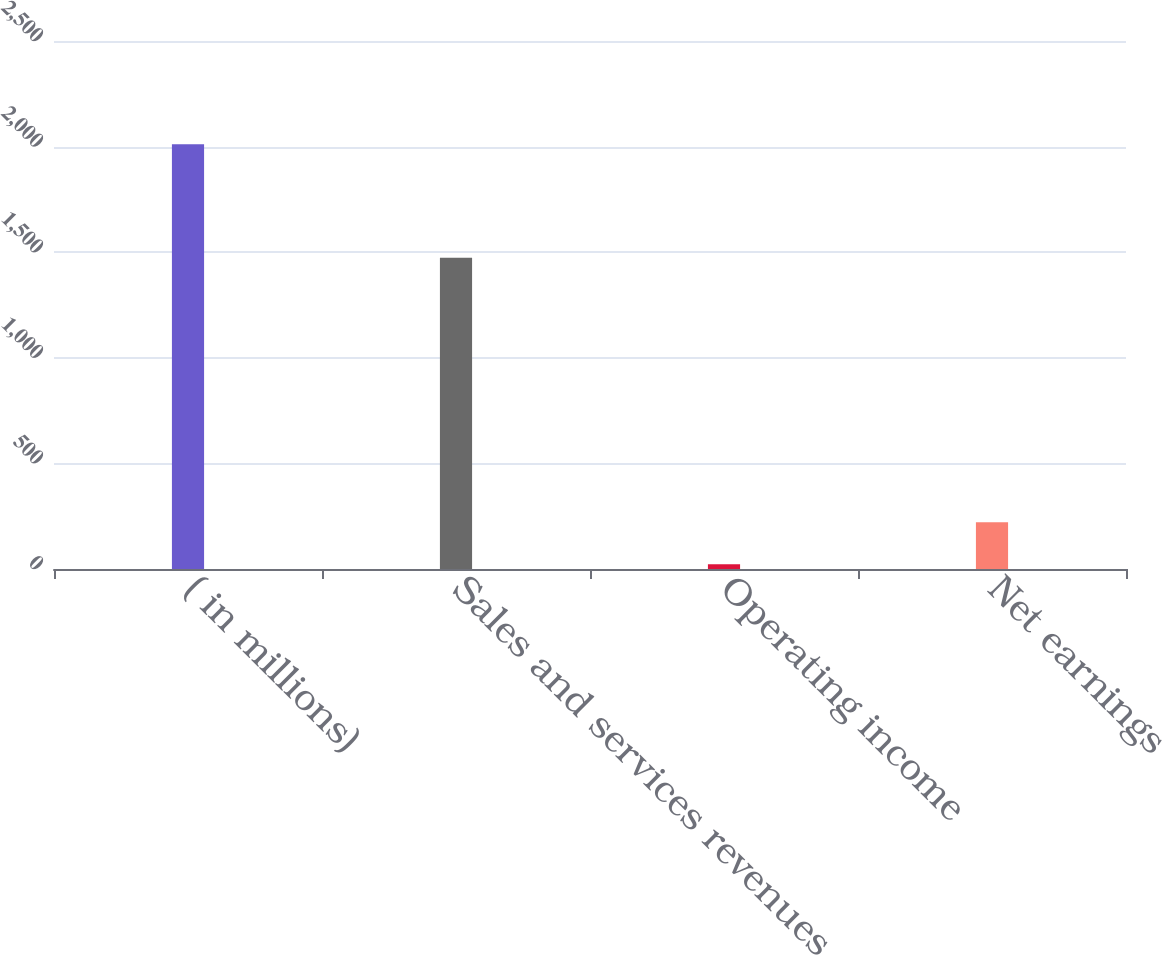Convert chart. <chart><loc_0><loc_0><loc_500><loc_500><bar_chart><fcel>( in millions)<fcel>Sales and services revenues<fcel>Operating income<fcel>Net earnings<nl><fcel>2011<fcel>1474<fcel>23<fcel>221.8<nl></chart> 